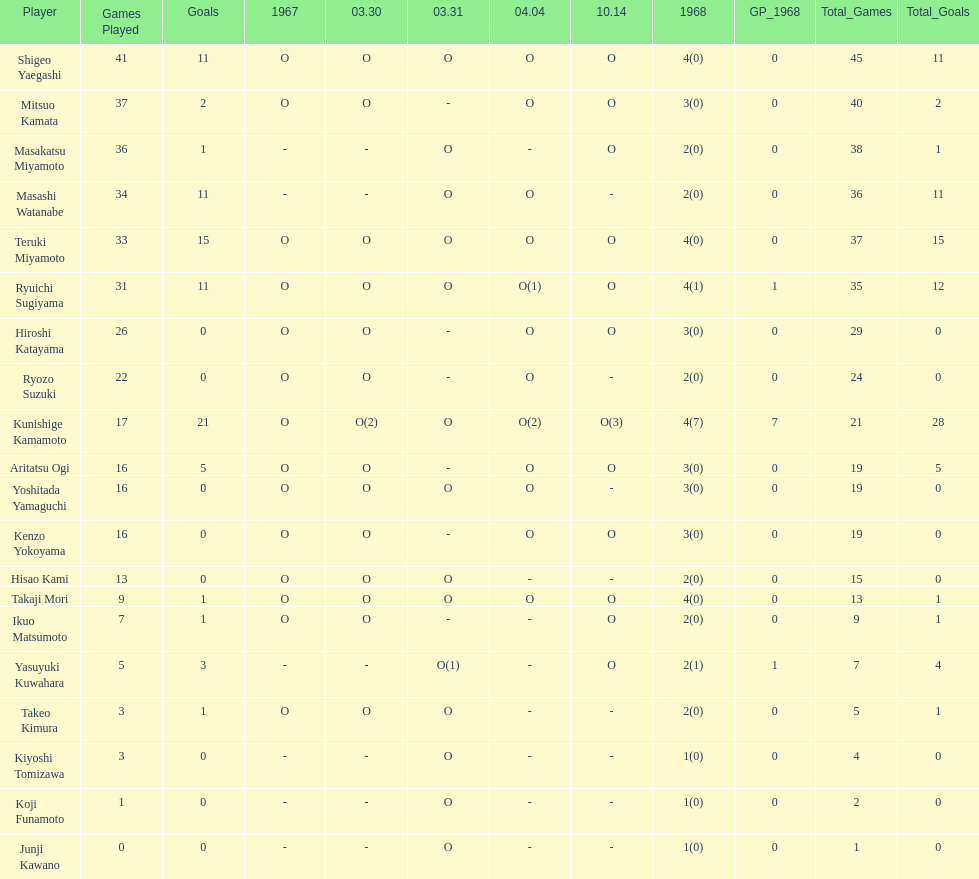Can you give me this table as a dict? {'header': ['Player', 'Games Played', 'Goals', '1967', '03.30', '03.31', '04.04', '10.14', '1968', 'GP_1968', 'Total_Games', 'Total_Goals'], 'rows': [['Shigeo Yaegashi', '41', '11', 'O', 'O', 'O', 'O', 'O', '4(0)', '0', '45', '11'], ['Mitsuo Kamata', '37', '2', 'O', 'O', '-', 'O', 'O', '3(0)', '0', '40', '2'], ['Masakatsu Miyamoto', '36', '1', '-', '-', 'O', '-', 'O', '2(0)', '0', '38', '1'], ['Masashi Watanabe', '34', '11', '-', '-', 'O', 'O', '-', '2(0)', '0', '36', '11'], ['Teruki Miyamoto', '33', '15', 'O', 'O', 'O', 'O', 'O', '4(0)', '0', '37', '15'], ['Ryuichi Sugiyama', '31', '11', 'O', 'O', 'O', 'O(1)', 'O', '4(1)', '1', '35', '12'], ['Hiroshi Katayama', '26', '0', 'O', 'O', '-', 'O', 'O', '3(0)', '0', '29', '0'], ['Ryozo Suzuki', '22', '0', 'O', 'O', '-', 'O', '-', '2(0)', '0', '24', '0'], ['Kunishige Kamamoto', '17', '21', 'O', 'O(2)', 'O', 'O(2)', 'O(3)', '4(7)', '7', '21', '28'], ['Aritatsu Ogi', '16', '5', 'O', 'O', '-', 'O', 'O', '3(0)', '0', '19', '5'], ['Yoshitada Yamaguchi', '16', '0', 'O', 'O', 'O', 'O', '-', '3(0)', '0', '19', '0'], ['Kenzo Yokoyama', '16', '0', 'O', 'O', '-', 'O', 'O', '3(0)', '0', '19', '0'], ['Hisao Kami', '13', '0', 'O', 'O', 'O', '-', '-', '2(0)', '0', '15', '0'], ['Takaji Mori', '9', '1', 'O', 'O', 'O', 'O', 'O', '4(0)', '0', '13', '1'], ['Ikuo Matsumoto', '7', '1', 'O', 'O', '-', '-', 'O', '2(0)', '0', '9', '1'], ['Yasuyuki Kuwahara', '5', '3', '-', '-', 'O(1)', '-', 'O', '2(1)', '1', '7', '4'], ['Takeo Kimura', '3', '1', 'O', 'O', 'O', '-', '-', '2(0)', '0', '5', '1'], ['Kiyoshi Tomizawa', '3', '0', '-', '-', 'O', '-', '-', '1(0)', '0', '4', '0'], ['Koji Funamoto', '1', '0', '-', '-', 'O', '-', '-', '1(0)', '0', '2', '0'], ['Junji Kawano', '0', '0', '-', '-', 'O', '-', '-', '1(0)', '0', '1', '0']]} How many players made an appearance that year? 20. 